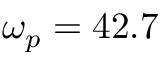<formula> <loc_0><loc_0><loc_500><loc_500>\omega _ { p } = 4 2 . 7</formula> 